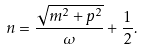<formula> <loc_0><loc_0><loc_500><loc_500>n = \frac { \sqrt { m ^ { 2 } + p ^ { 2 } } } { \omega } + \frac { 1 } { 2 } .</formula> 